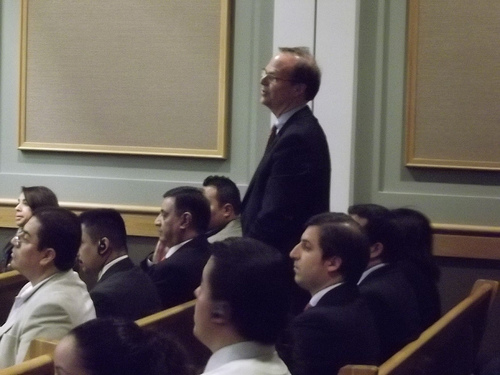<image>
Is there a man to the left of the bench? No. The man is not to the left of the bench. From this viewpoint, they have a different horizontal relationship. 